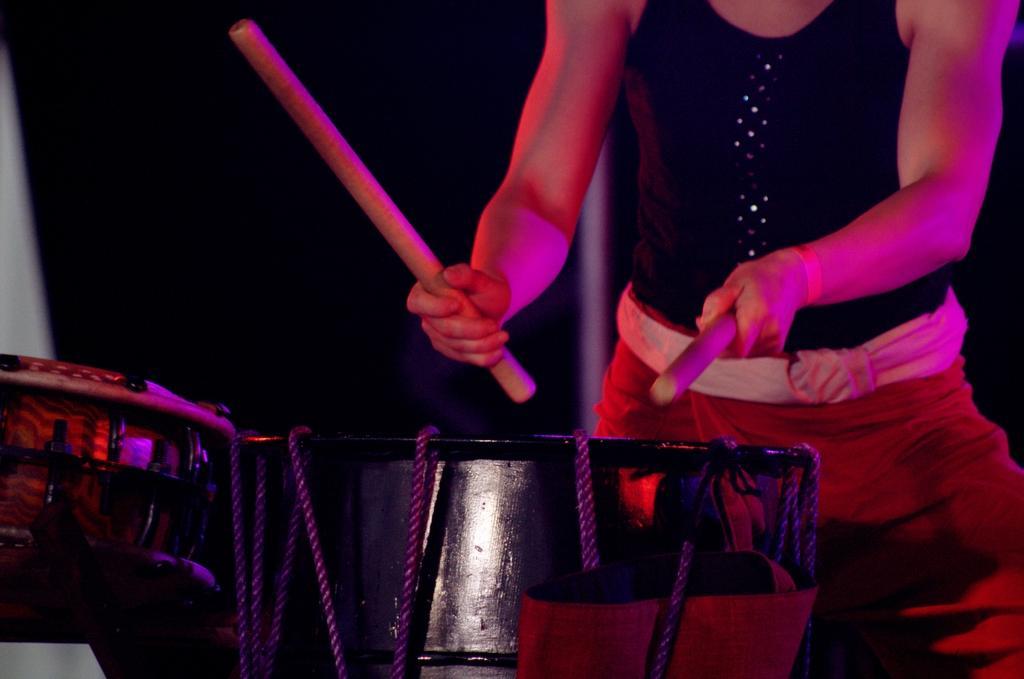Describe this image in one or two sentences. This picture shows a woman playing drums with sticks in her hand. 